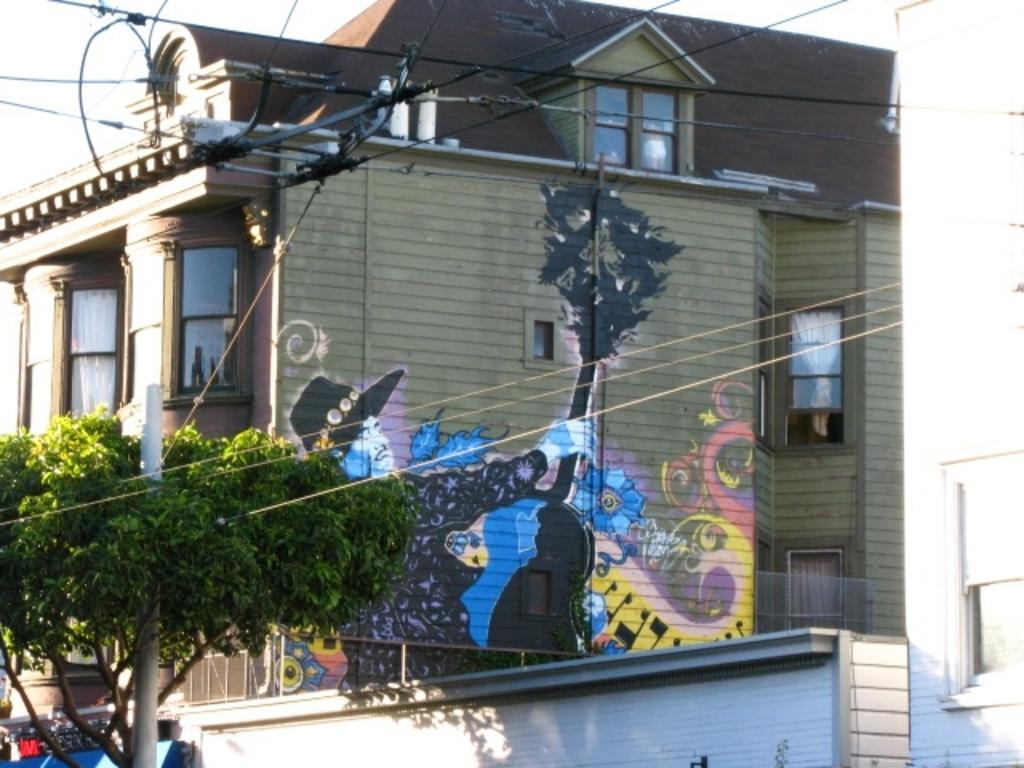What is located at the front of the image? There is a tree in the front of the image. What can be seen in the image besides the tree? There is a pole, wires, and a building in the background of the image. What is on the wall of the building? There is a painting on the wall of the building. What type of crime is being committed in the image? There is no crime being committed in the image; it features a tree, pole, wires, and a building with a painting on the wall. What kind of beast can be seen interacting with the painting on the wall? There is no beast present in the image; it only features a tree, pole, wires, and a building with a painting on the wall. 